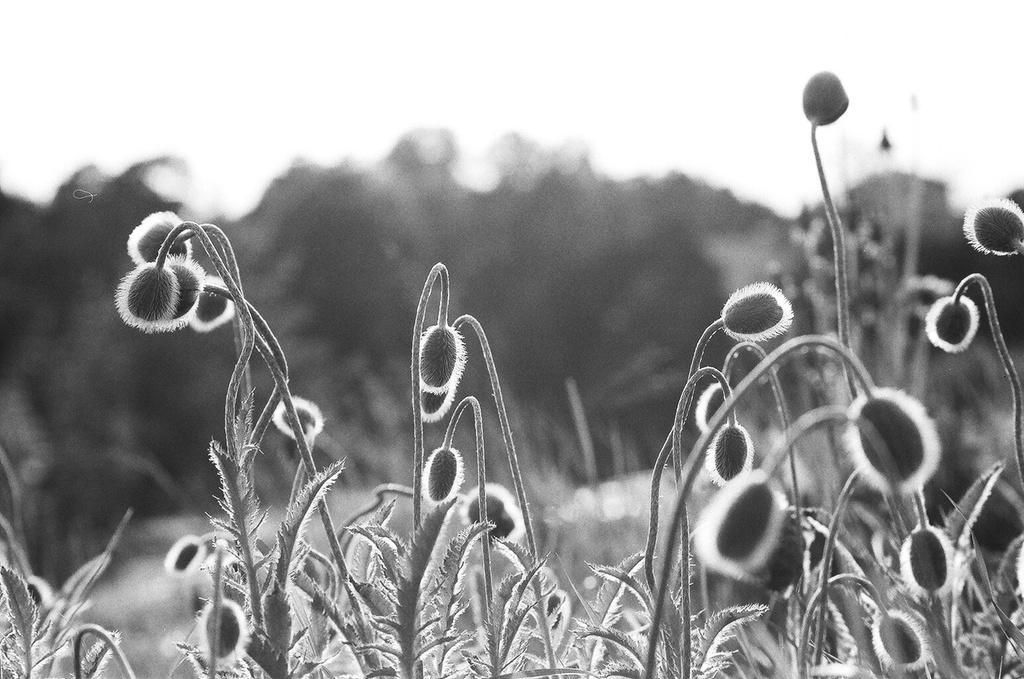Could you give a brief overview of what you see in this image? This is a black and white image where we can see plants. The background of the image is blurred. 